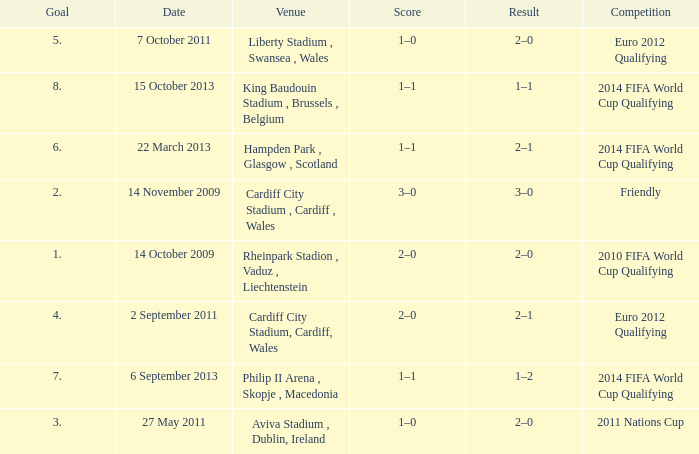What is the Venue for Goal number 1? Rheinpark Stadion , Vaduz , Liechtenstein. 